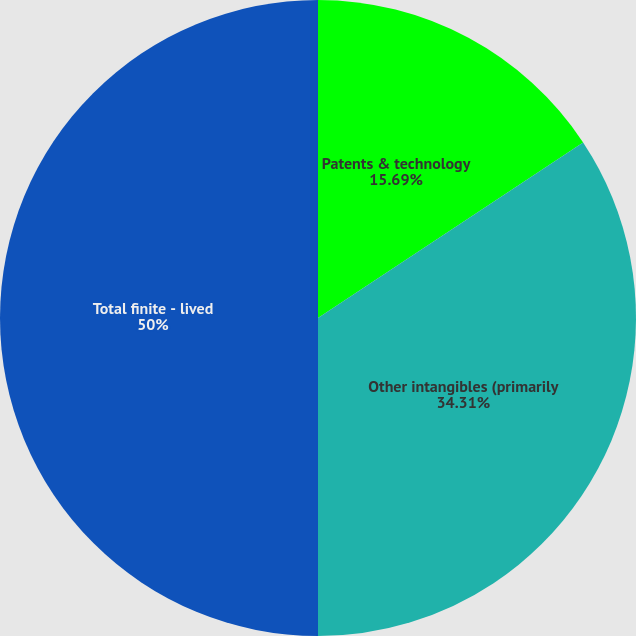<chart> <loc_0><loc_0><loc_500><loc_500><pie_chart><fcel>Patents & technology<fcel>Other intangibles (primarily<fcel>Total finite - lived<nl><fcel>15.69%<fcel>34.31%<fcel>50.0%<nl></chart> 